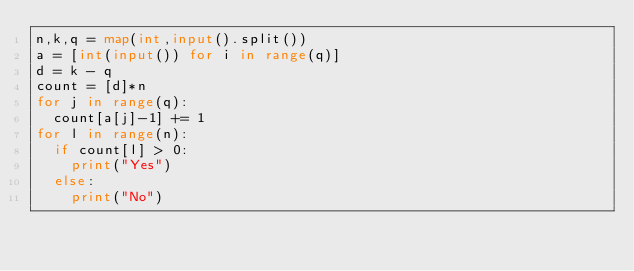<code> <loc_0><loc_0><loc_500><loc_500><_Python_>n,k,q = map(int,input().split())
a = [int(input()) for i in range(q)]
d = k - q
count = [d]*n
for j in range(q):
  count[a[j]-1] += 1
for l in range(n):
  if count[l] > 0:
    print("Yes")
  else:
    print("No")</code> 